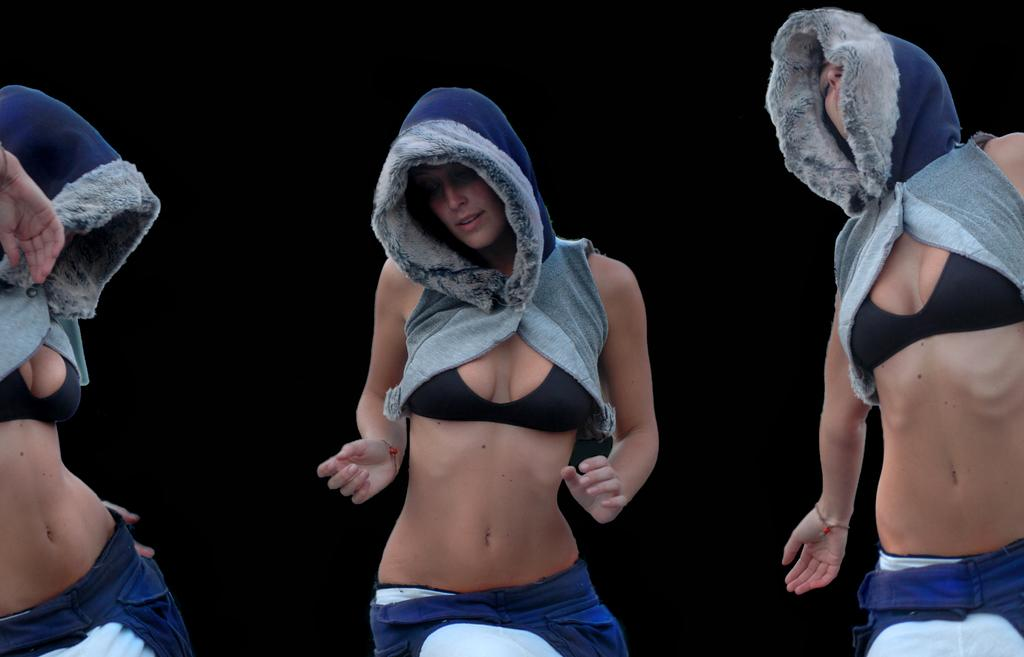What are the people in the image doing? The people in the image are dancing. What can be observed about the lighting in the image? The background of the image is dark. What type of business is being conducted in the image? There is no indication of a business or any business-related activities in the image. What kind of bread can be seen on the table in the image? There is no table or bread present in the image; it features people dancing against a dark background. 